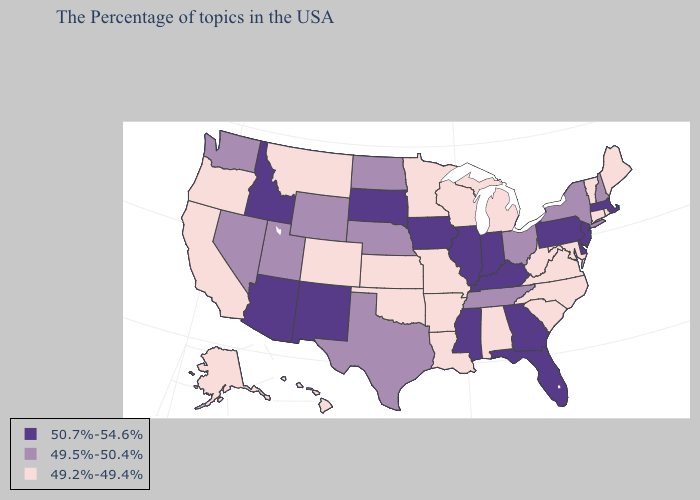Which states have the highest value in the USA?
Concise answer only. Massachusetts, New Jersey, Delaware, Pennsylvania, Florida, Georgia, Kentucky, Indiana, Illinois, Mississippi, Iowa, South Dakota, New Mexico, Arizona, Idaho. Name the states that have a value in the range 49.2%-49.4%?
Keep it brief. Maine, Rhode Island, Vermont, Connecticut, Maryland, Virginia, North Carolina, South Carolina, West Virginia, Michigan, Alabama, Wisconsin, Louisiana, Missouri, Arkansas, Minnesota, Kansas, Oklahoma, Colorado, Montana, California, Oregon, Alaska, Hawaii. Does Idaho have the lowest value in the West?
Quick response, please. No. Does Arizona have the same value as Illinois?
Write a very short answer. Yes. What is the lowest value in states that border Wisconsin?
Give a very brief answer. 49.2%-49.4%. Name the states that have a value in the range 49.5%-50.4%?
Answer briefly. New Hampshire, New York, Ohio, Tennessee, Nebraska, Texas, North Dakota, Wyoming, Utah, Nevada, Washington. What is the highest value in the USA?
Keep it brief. 50.7%-54.6%. What is the highest value in the USA?
Concise answer only. 50.7%-54.6%. Which states have the lowest value in the Northeast?
Keep it brief. Maine, Rhode Island, Vermont, Connecticut. Name the states that have a value in the range 49.5%-50.4%?
Keep it brief. New Hampshire, New York, Ohio, Tennessee, Nebraska, Texas, North Dakota, Wyoming, Utah, Nevada, Washington. Does Arkansas have the lowest value in the USA?
Be succinct. Yes. What is the highest value in the Northeast ?
Answer briefly. 50.7%-54.6%. Does Florida have the highest value in the South?
Keep it brief. Yes. What is the value of Pennsylvania?
Answer briefly. 50.7%-54.6%. 